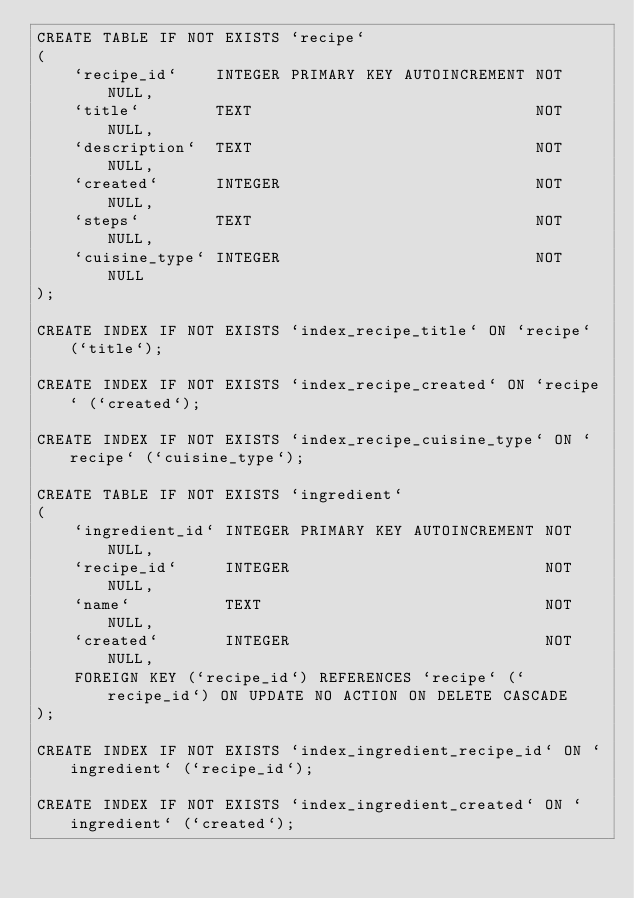Convert code to text. <code><loc_0><loc_0><loc_500><loc_500><_SQL_>CREATE TABLE IF NOT EXISTS `recipe`
(
    `recipe_id`    INTEGER PRIMARY KEY AUTOINCREMENT NOT NULL,
    `title`        TEXT                              NOT NULL,
    `description`  TEXT                              NOT NULL,
    `created`      INTEGER                           NOT NULL,
    `steps`        TEXT                              NOT NULL,
    `cuisine_type` INTEGER                           NOT NULL
);

CREATE INDEX IF NOT EXISTS `index_recipe_title` ON `recipe` (`title`);

CREATE INDEX IF NOT EXISTS `index_recipe_created` ON `recipe` (`created`);

CREATE INDEX IF NOT EXISTS `index_recipe_cuisine_type` ON `recipe` (`cuisine_type`);

CREATE TABLE IF NOT EXISTS `ingredient`
(
    `ingredient_id` INTEGER PRIMARY KEY AUTOINCREMENT NOT NULL,
    `recipe_id`     INTEGER                           NOT NULL,
    `name`          TEXT                              NOT NULL,
    `created`       INTEGER                           NOT NULL,
    FOREIGN KEY (`recipe_id`) REFERENCES `recipe` (`recipe_id`) ON UPDATE NO ACTION ON DELETE CASCADE
);

CREATE INDEX IF NOT EXISTS `index_ingredient_recipe_id` ON `ingredient` (`recipe_id`);

CREATE INDEX IF NOT EXISTS `index_ingredient_created` ON `ingredient` (`created`);

</code> 